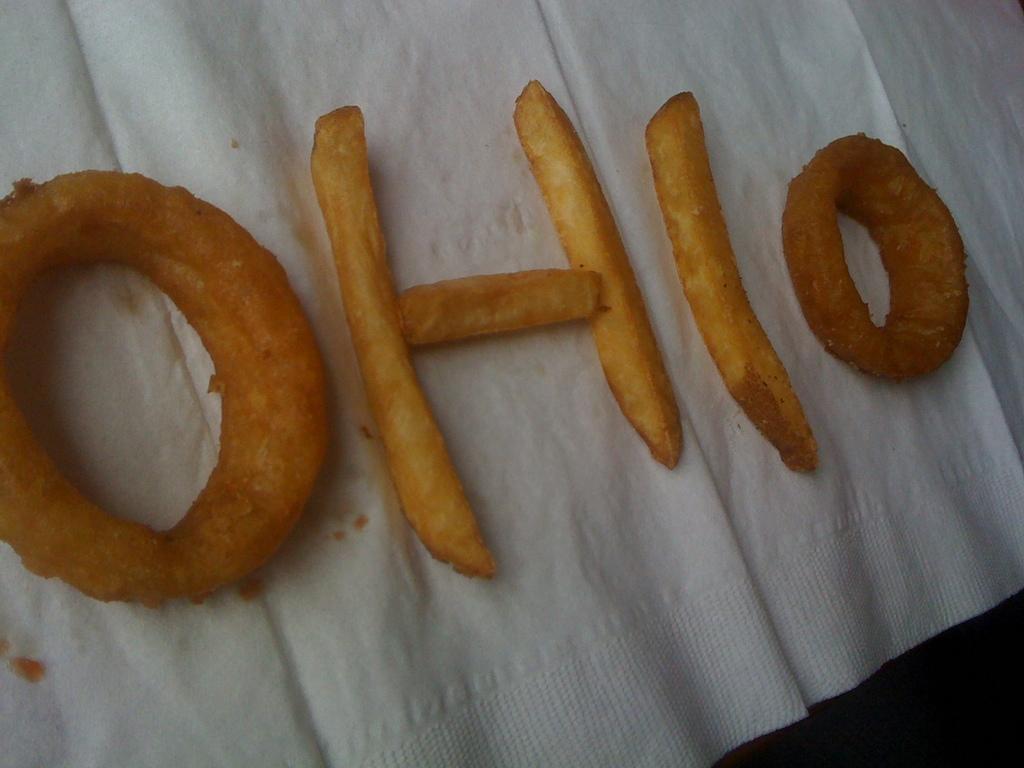Can you describe this image briefly? In the picture we can see a white cloth on it, we can see snake in the shape of a spelling OHIO. 